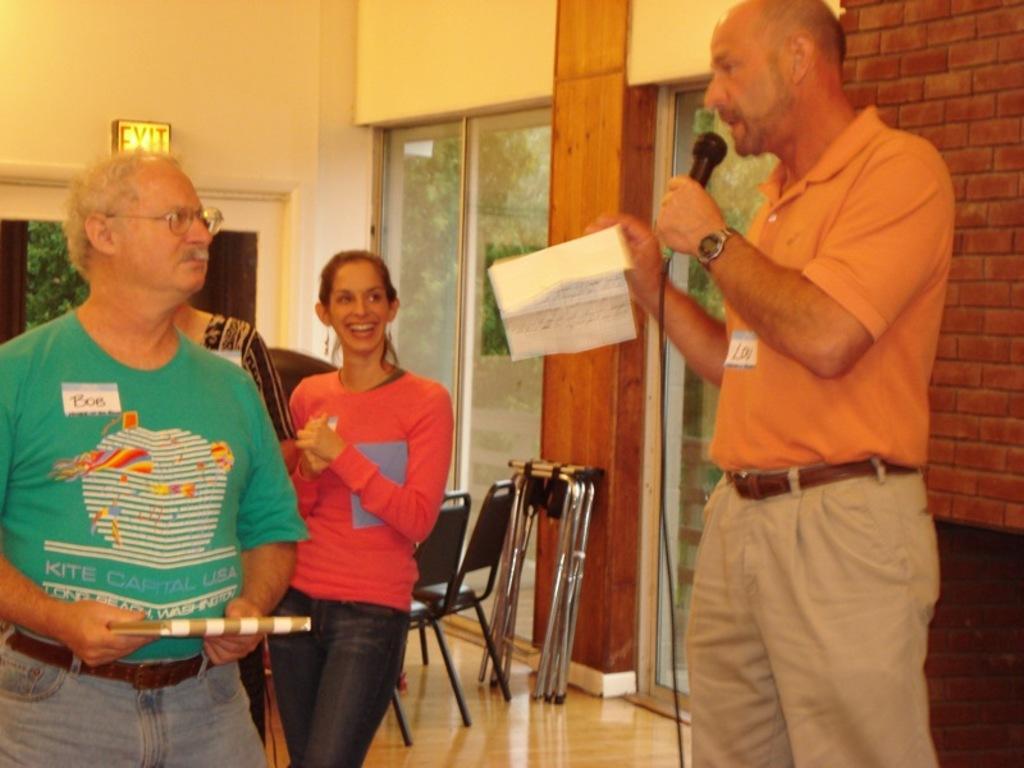Could you give a brief overview of what you see in this image? In this image we can see there are people standing and we can see the person holding mic and paper and the other person holding book. At the back there are chairs, stand, wall, windows and exit board. 